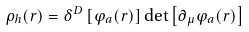<formula> <loc_0><loc_0><loc_500><loc_500>\rho _ { h } ( r ) = \delta ^ { D } \left [ \varphi _ { a } ( r ) \right ] \det \left [ \partial _ { \mu } \varphi _ { a } ( r ) \right ]</formula> 